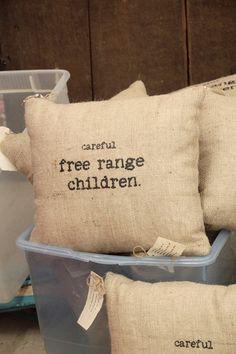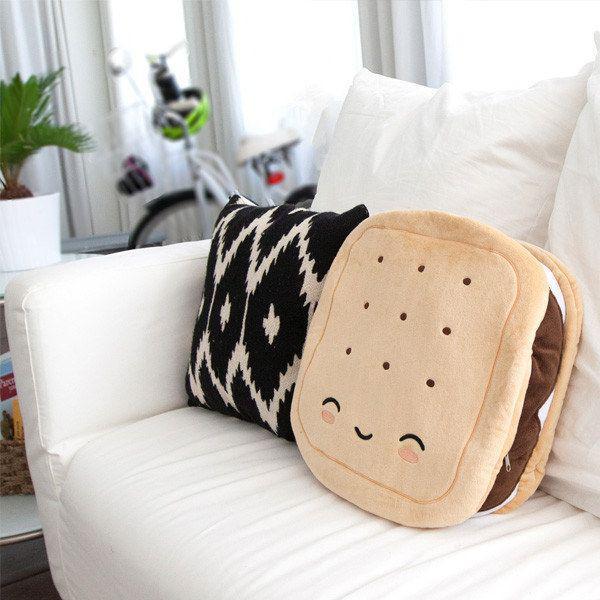The first image is the image on the left, the second image is the image on the right. Assess this claim about the two images: "A single burlap covered pillow sits on a wooden surface in the image on the left.". Correct or not? Answer yes or no. No. The first image is the image on the left, the second image is the image on the right. Analyze the images presented: Is the assertion "An image shows one square pillow made of burlap decorated with pumpkin shapes." valid? Answer yes or no. No. 